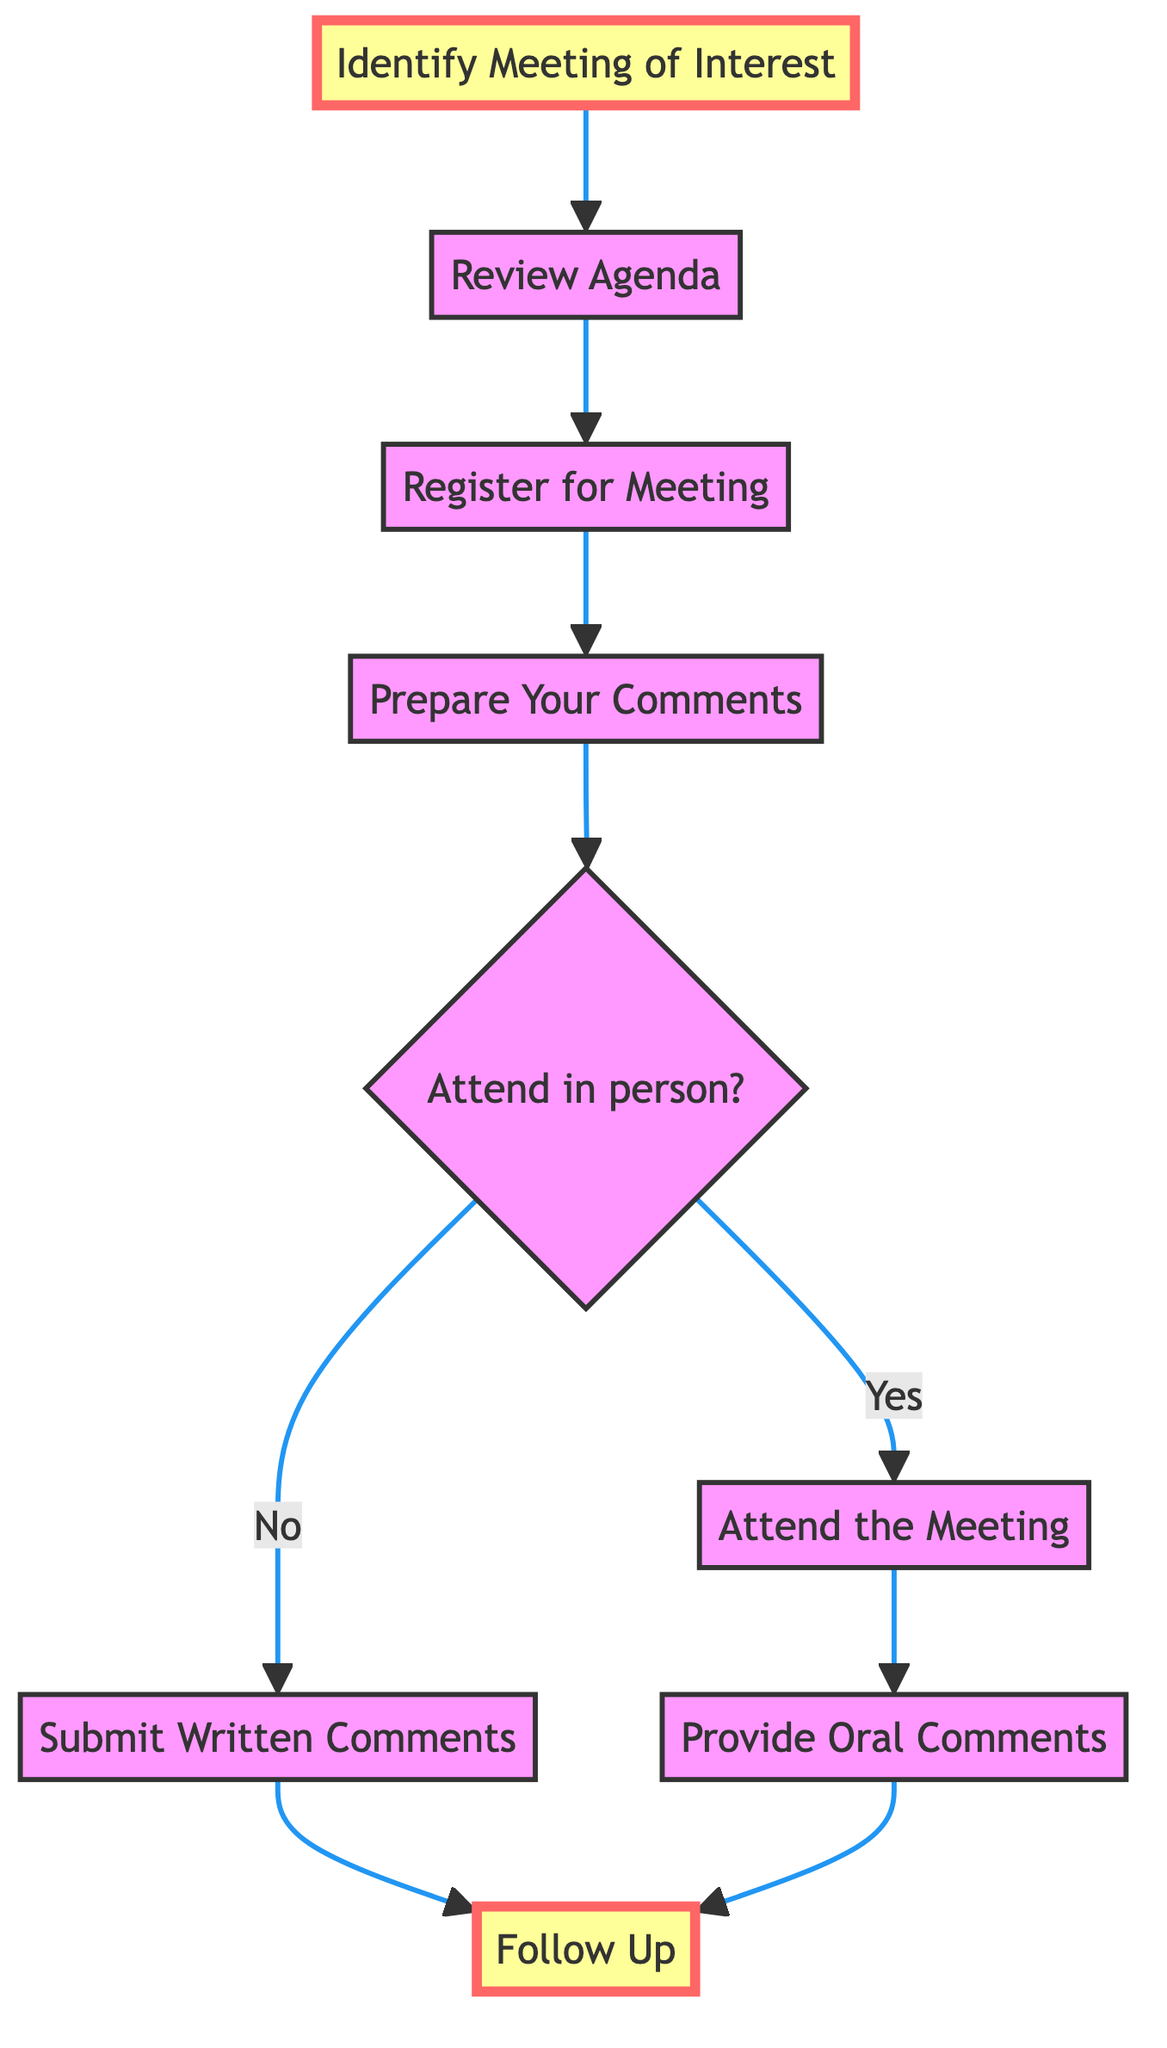What is the first step in the process? The first step in the process, as indicated in the diagram, is "Identify Meeting of Interest". This is shown at the top of the flowchart and is the initial point that leads to the subsequent steps.
Answer: Identify Meeting of Interest How many steps are there in total? By counting each distinct node in the flowchart, there are eight main steps throughout the entire process, leading from identifying a meeting to following up afterward.
Answer: Eight What happens if you cannot attend the meeting? According to the flowchart, if you cannot attend the meeting, you should submit written comments via the online public comment form, which is indicated by the decision node for attending in person or not.
Answer: Submit Written Comments What is the decision point in the process? The decision point in the process is at the step "Attend in person?", which leads to two divergent paths: attending in person or submitting written comments instead.
Answer: Attend in person? What follows after "Provide Oral Comments"? After "Provide Oral Comments", the next step in the process is "Follow Up", indicating that one should take action after delivering their comments during the meeting.
Answer: Follow Up Which step requires preparation of comments? The step that requires preparation of comments is "Prepare Your Comments", where individuals are advised to draft their comments or questions ahead of time to ensure clarity and relevance.
Answer: Prepare Your Comments What is the last step in the process? The last step in the process, as shown in the flowchart, is "Follow Up", which occurs after the meeting to ensure that any action items or responses are addressed.
Answer: Follow Up What action is recommended after reviewing the agenda? After reviewing the agenda, the recommended action is to "Register for Meeting", which indicates that one must sign up to attend the meeting either in person or online.
Answer: Register for Meeting What is the connection between "Review Agenda" and "Prepare Your Comments"? The connection is sequential; after completing the "Review Agenda" step, the next step is to "Prepare Your Comments", indicating that understanding the agenda is essential for drafting relevant comments.
Answer: Prepare Your Comments 